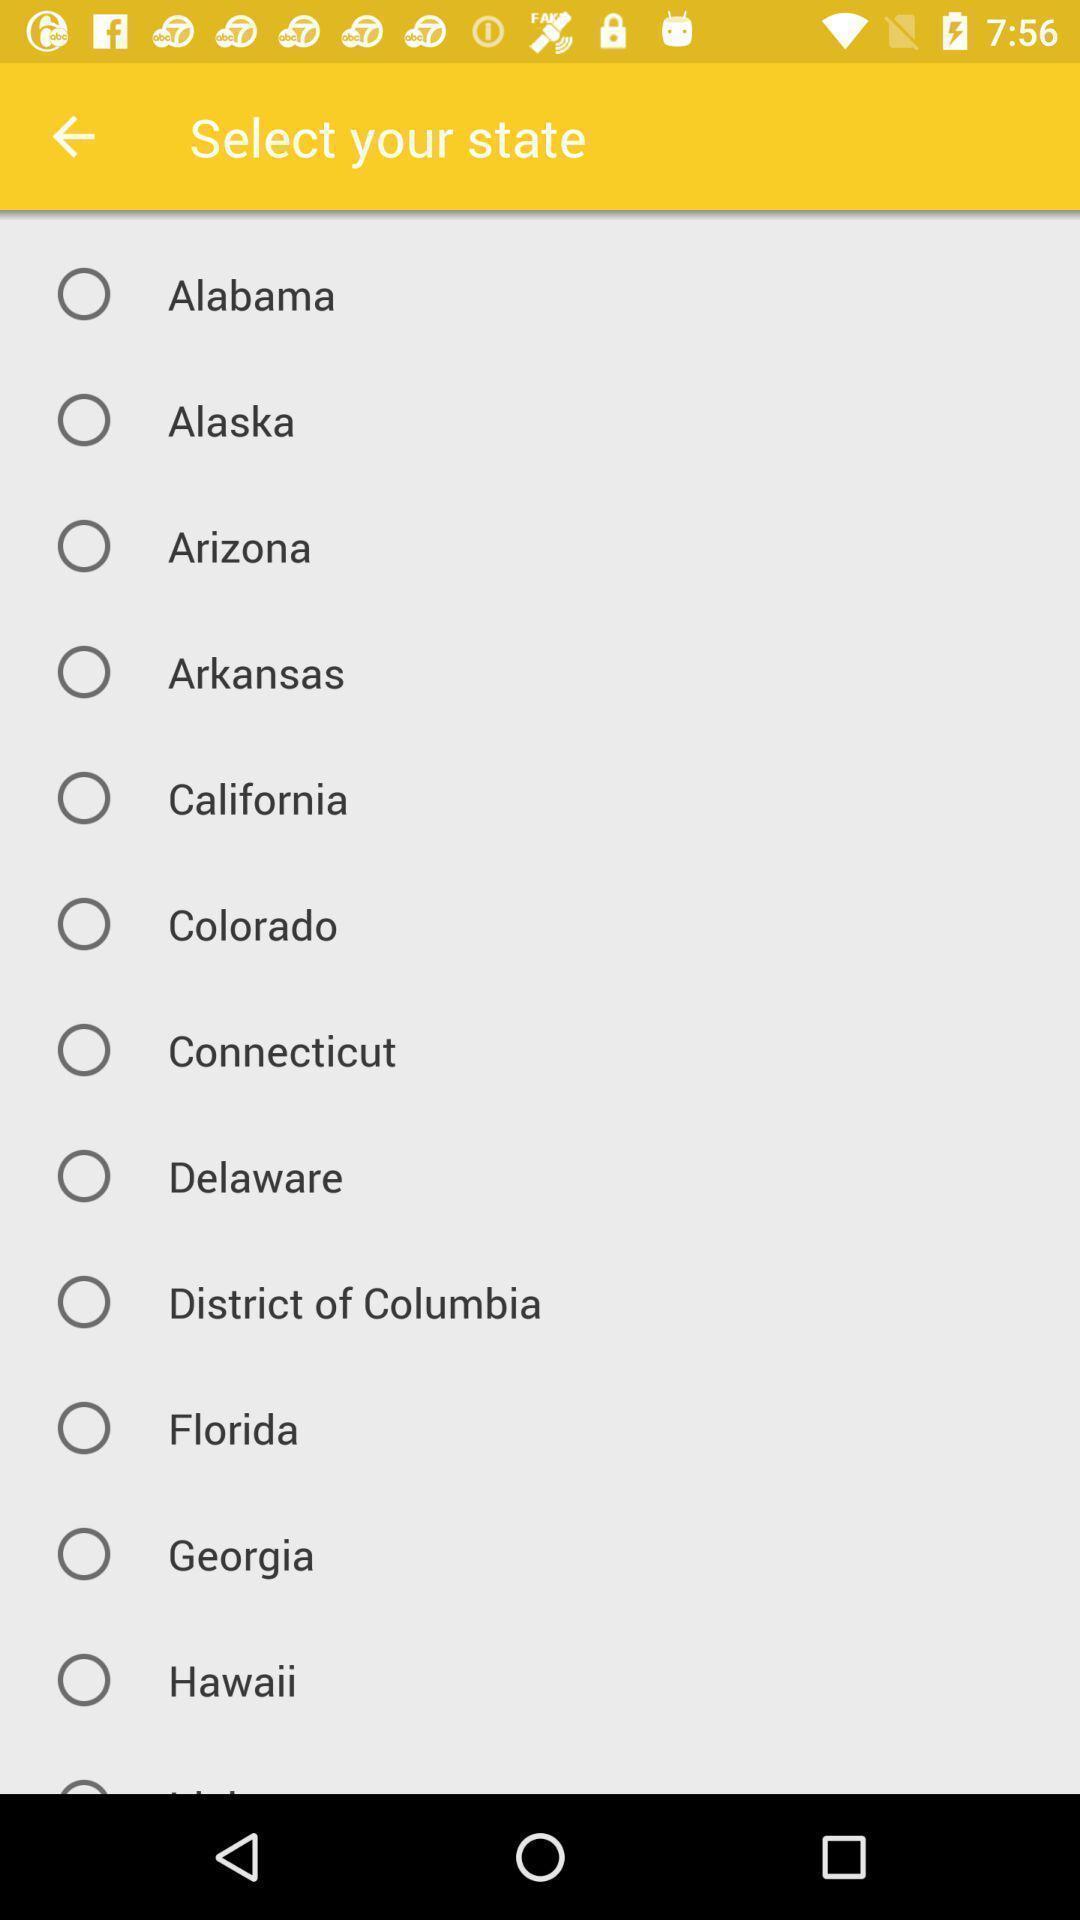Tell me what you see in this picture. Us states list showing in this page. 